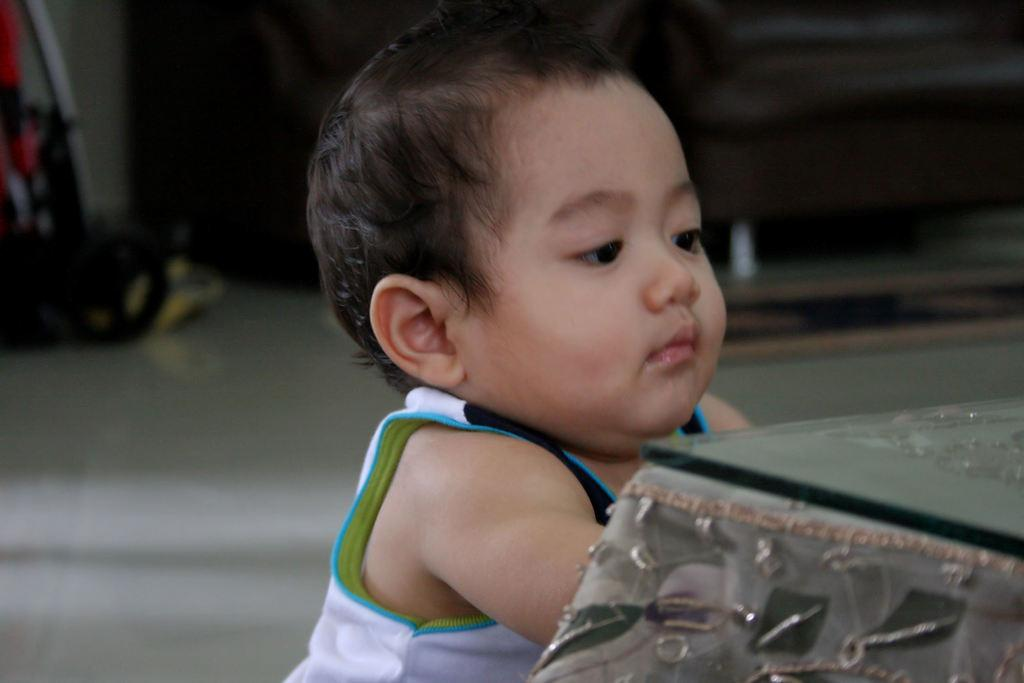What is the main subject of the picture? The main subject of the picture is a kid. What can be seen in the background of the picture? There appears to be a baby trolley in the background of the picture. What type of sweater is the kid wearing in the picture? The provided facts do not mention any clothing the kid is wearing, so we cannot determine if the kid is wearing a sweater or its type. 